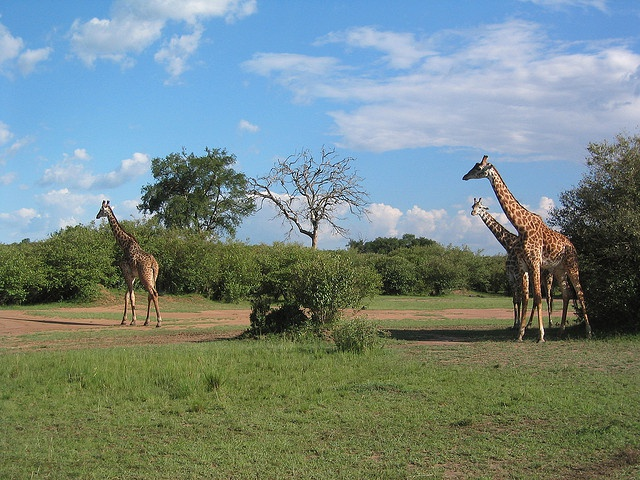Describe the objects in this image and their specific colors. I can see giraffe in darkgray, black, maroon, and gray tones, giraffe in darkgray, black, gray, maroon, and tan tones, and giraffe in darkgray, black, and gray tones in this image. 